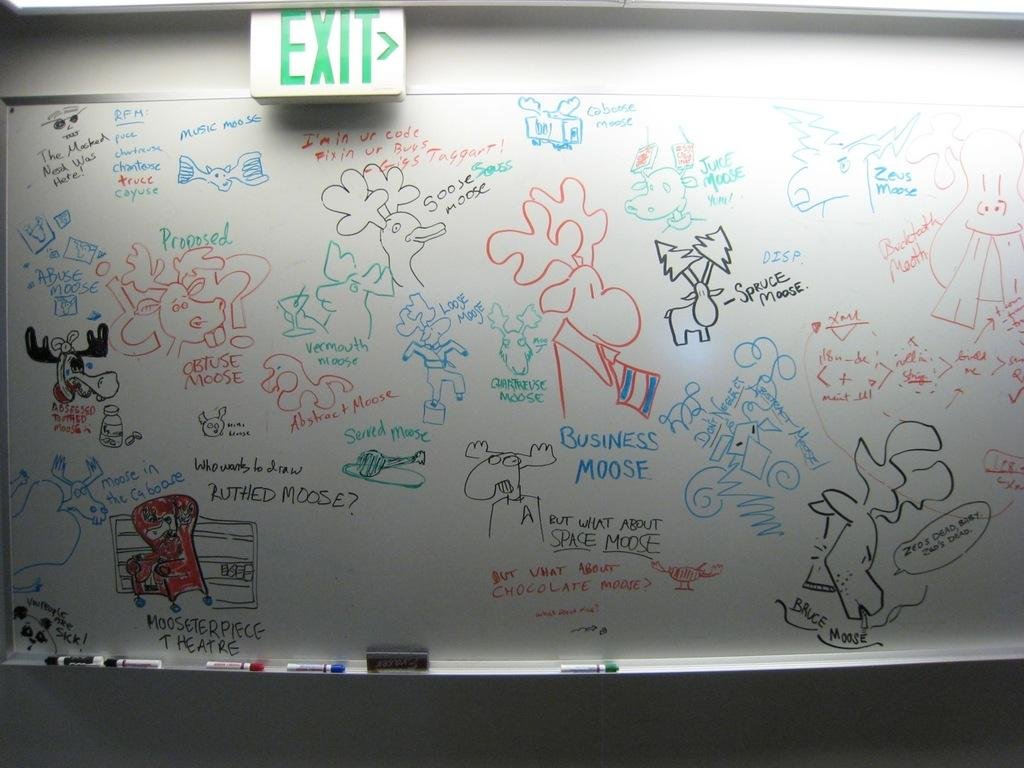<image>
Offer a succinct explanation of the picture presented. A whiteboard with various colorful drawings and an exit sign above it. 